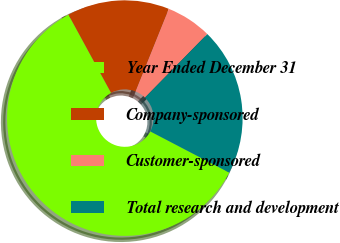Convert chart. <chart><loc_0><loc_0><loc_500><loc_500><pie_chart><fcel>Year Ended December 31<fcel>Company-sponsored<fcel>Customer-sponsored<fcel>Total research and development<nl><fcel>59.41%<fcel>14.02%<fcel>6.27%<fcel>20.3%<nl></chart> 